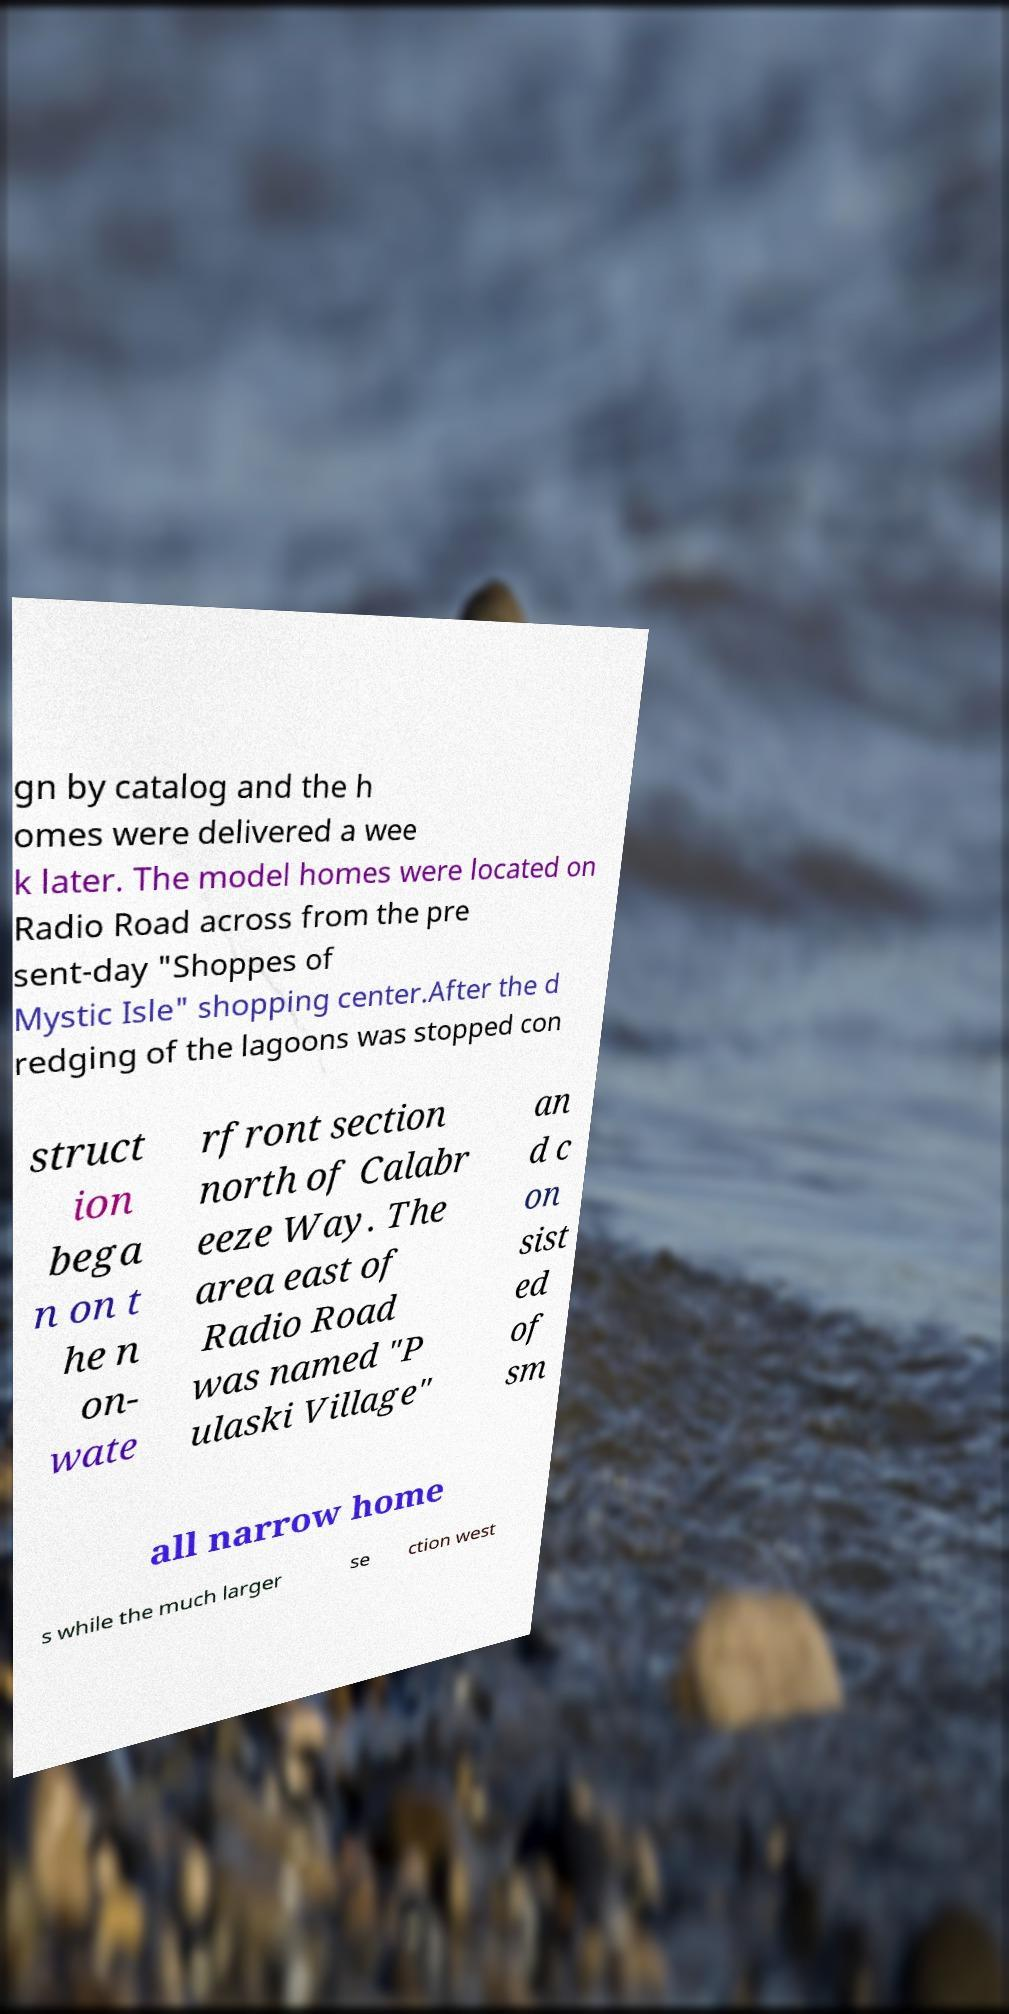I need the written content from this picture converted into text. Can you do that? gn by catalog and the h omes were delivered a wee k later. The model homes were located on Radio Road across from the pre sent-day "Shoppes of Mystic Isle" shopping center.After the d redging of the lagoons was stopped con struct ion bega n on t he n on- wate rfront section north of Calabr eeze Way. The area east of Radio Road was named "P ulaski Village" an d c on sist ed of sm all narrow home s while the much larger se ction west 